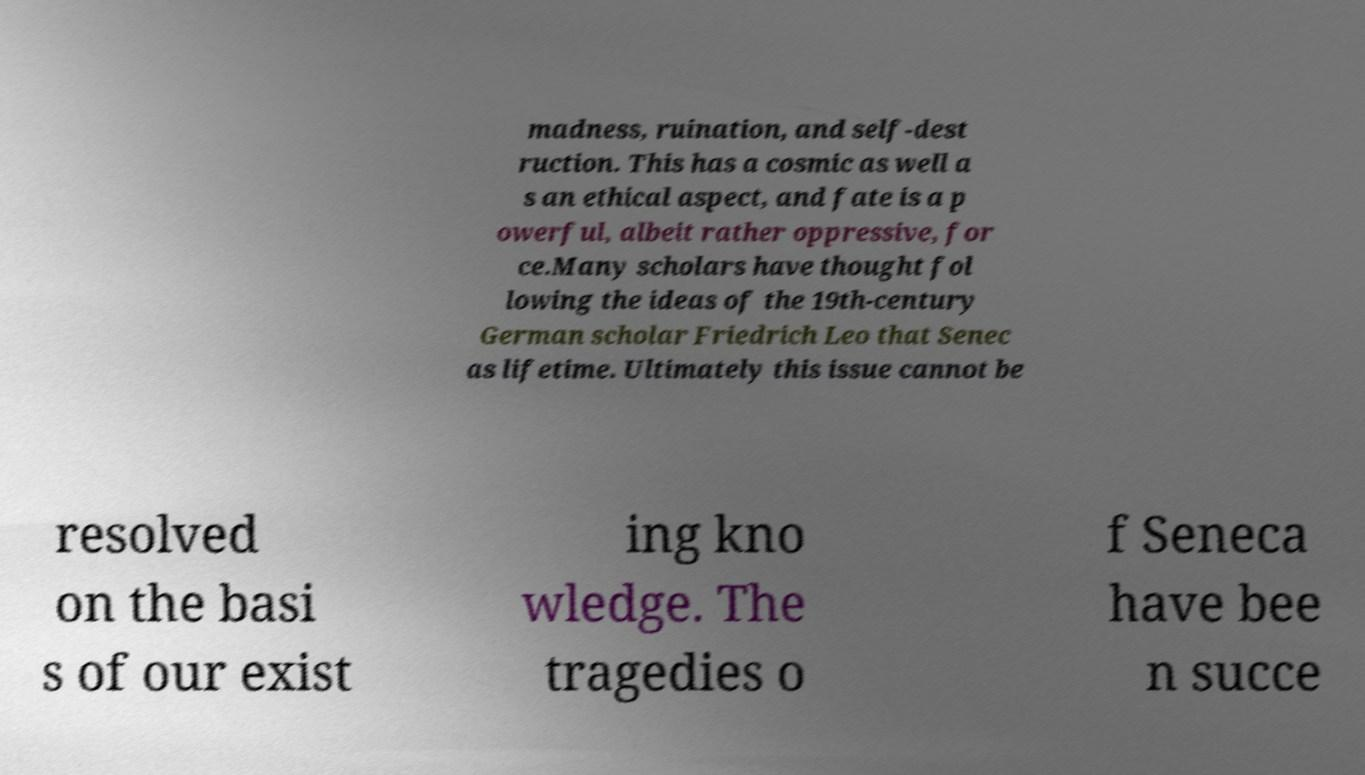Can you read and provide the text displayed in the image?This photo seems to have some interesting text. Can you extract and type it out for me? madness, ruination, and self-dest ruction. This has a cosmic as well a s an ethical aspect, and fate is a p owerful, albeit rather oppressive, for ce.Many scholars have thought fol lowing the ideas of the 19th-century German scholar Friedrich Leo that Senec as lifetime. Ultimately this issue cannot be resolved on the basi s of our exist ing kno wledge. The tragedies o f Seneca have bee n succe 